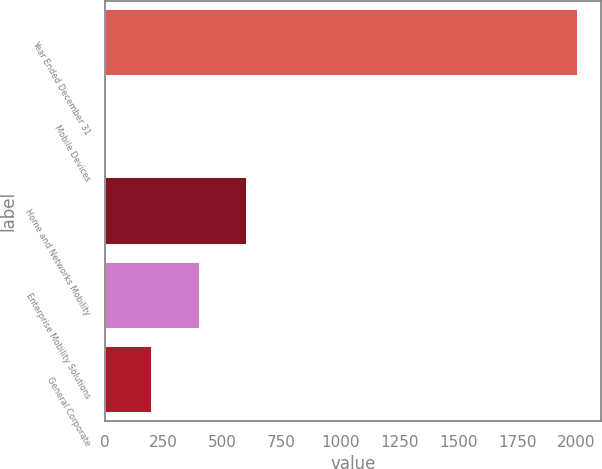Convert chart to OTSL. <chart><loc_0><loc_0><loc_500><loc_500><bar_chart><fcel>Year Ended December 31<fcel>Mobile Devices<fcel>Home and Networks Mobility<fcel>Enterprise Mobility Solutions<fcel>General Corporate<nl><fcel>2006<fcel>1<fcel>602.5<fcel>402<fcel>201.5<nl></chart> 